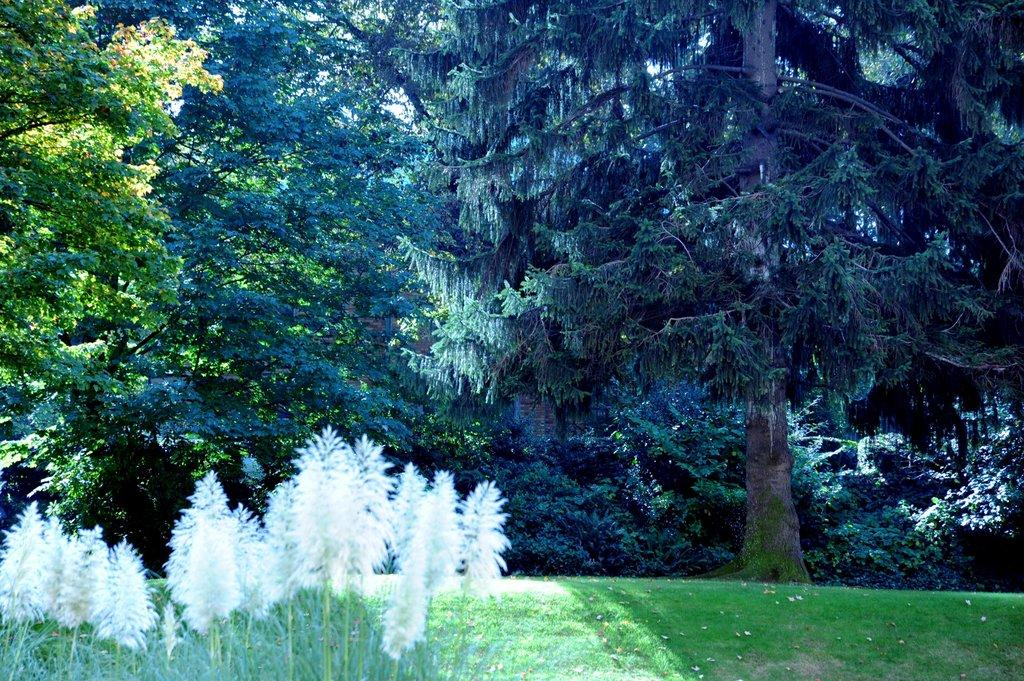What type of natural environment is depicted in the image? The image features grass, trees, and plants. Can you describe the vegetation present in the image? There is grass, trees, and plants visible in the image. What type of story is being told by the cherry tree in the image? There is no cherry tree present in the image, and therefore no story can be attributed to it. 